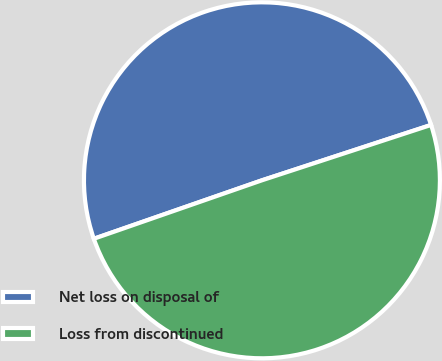<chart> <loc_0><loc_0><loc_500><loc_500><pie_chart><fcel>Net loss on disposal of<fcel>Loss from discontinued<nl><fcel>50.29%<fcel>49.71%<nl></chart> 